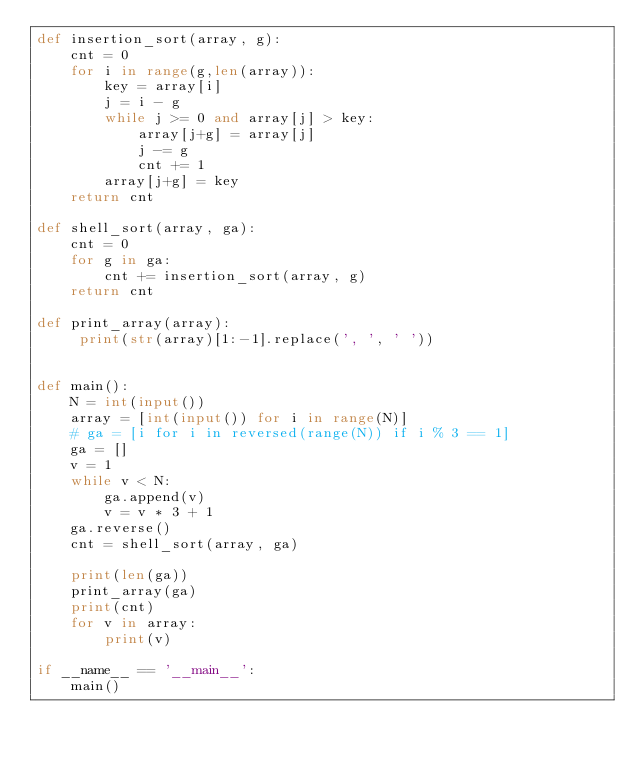<code> <loc_0><loc_0><loc_500><loc_500><_Python_>def insertion_sort(array, g):
    cnt = 0
    for i in range(g,len(array)):
        key = array[i]
        j = i - g
        while j >= 0 and array[j] > key:
            array[j+g] = array[j]
            j -= g
            cnt += 1
        array[j+g] = key
    return cnt

def shell_sort(array, ga):
    cnt = 0
    for g in ga:
        cnt += insertion_sort(array, g)
    return cnt

def print_array(array):
     print(str(array)[1:-1].replace(', ', ' '))


def main():
    N = int(input())
    array = [int(input()) for i in range(N)]
    # ga = [i for i in reversed(range(N)) if i % 3 == 1]
    ga = []
    v = 1
    while v < N:
        ga.append(v)
        v = v * 3 + 1
    ga.reverse()
    cnt = shell_sort(array, ga)

    print(len(ga))
    print_array(ga)
    print(cnt)
    for v in array:
        print(v)

if __name__ == '__main__':
    main()</code> 